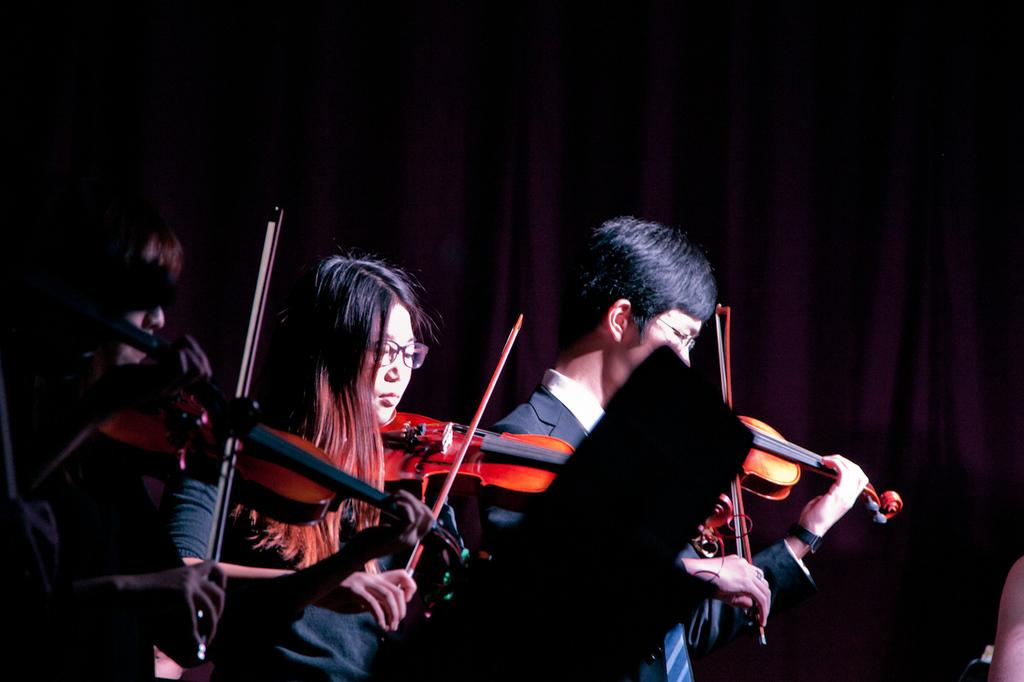How many people are in the image? There are three people in the image. What are the people in the image doing? Each of the three people is playing a violin. What type of paper is the self-aware knowledge using to write its answers? There is no paper, self-awareness, or knowledge present in the image, as it features three people playing violins. 